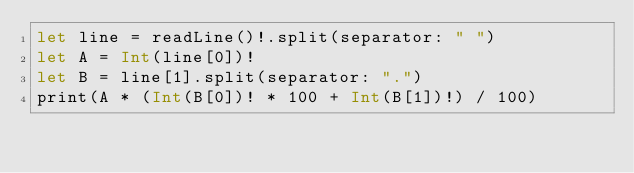<code> <loc_0><loc_0><loc_500><loc_500><_Swift_>let line = readLine()!.split(separator: " ")
let A = Int(line[0])!
let B = line[1].split(separator: ".")
print(A * (Int(B[0])! * 100 + Int(B[1])!) / 100)
</code> 